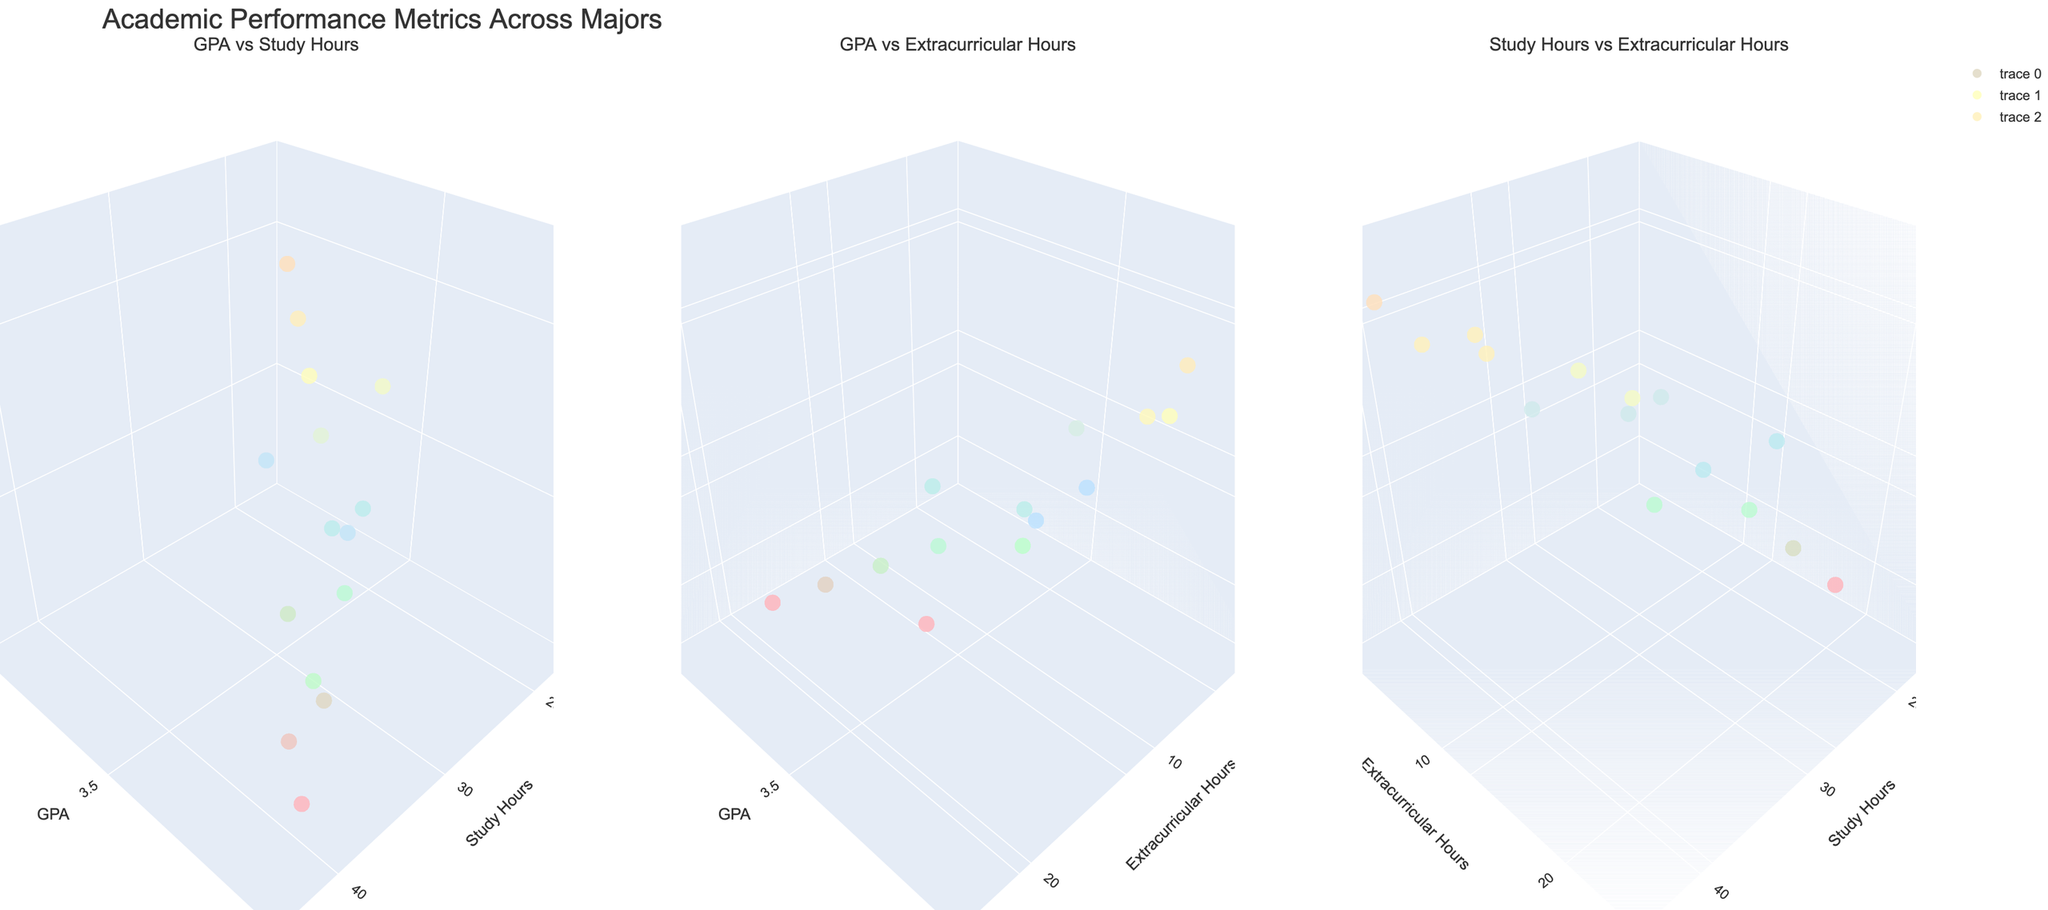What's the title of the figure? The title of the figure is located at the top of the plot and provides a general description of what the figure represents.
Answer: Academic Performance Metrics Across Majors How many subplots are there in the figure? By counting the separate regions within the figure, each designated as an individual plot, we can determine the number of subplots.
Answer: 3 Which major has the least number of study hours per week? The figure shows the distribution of study hours per week across different majors. By identifying the point with the lowest x-value in the subplot titled "GPA vs Study Hours," we find "Business Administration" as it has 20 study hours.
Answer: Business Administration What is the relationship between extracurricular hours and study hours for Psychology? By locating the "Psychology" data points in the subplot "Study Hours vs Extracurricular Hours," we observe that it has 15 extracurricular hours and 20 study hours.
Answer: 15 extracurricular hours, 20 study hours Which major has the highest GPA while having high study hours? In the subplot "GPA vs Study Hours," look for the highest point on the GPA axis combined with a high value on the Study Hours axis. The point representing "Engineering" stands out as it has a GPA of 3.9 and 40 study hours per week.
Answer: Engineering Compare the GPA and study hours for Computer Science and Mathematics majors. By locating both data points in the "GPA vs Study Hours" subplot: 
- Computer Science: GPA 3.8, Study Hours 35
- Mathematics: GPA 3.8, Study Hours 38
Answer: Computer Science: 3.8 GPA, 35 Study Hours; Mathematics: 3.8 GPA, 38 Study Hours Which major has the highest number of extracurricular hours and what is its GPA? By identifying the point with the highest z-value in the "GPA vs Extracurricular Hours" subplot, we see "Business Administration" at 20 extracurricular hours. Its GPA value is observed to be 3.2.
Answer: Business Administration, 3.2 GPA What range do the study hours fall into across all majors? Observing the x-axes in the subplots dealing with study hours, the minimum value is 20, and the maximum value is 40.
Answer: 20 to 40 hours Is there any major with both high study hours and high extracurricular hours? By checking for any overlapping high values in the "Study Hours vs Extracurricular Hours" subplot, we see that no major has both values significantly high above others.
Answer: No 